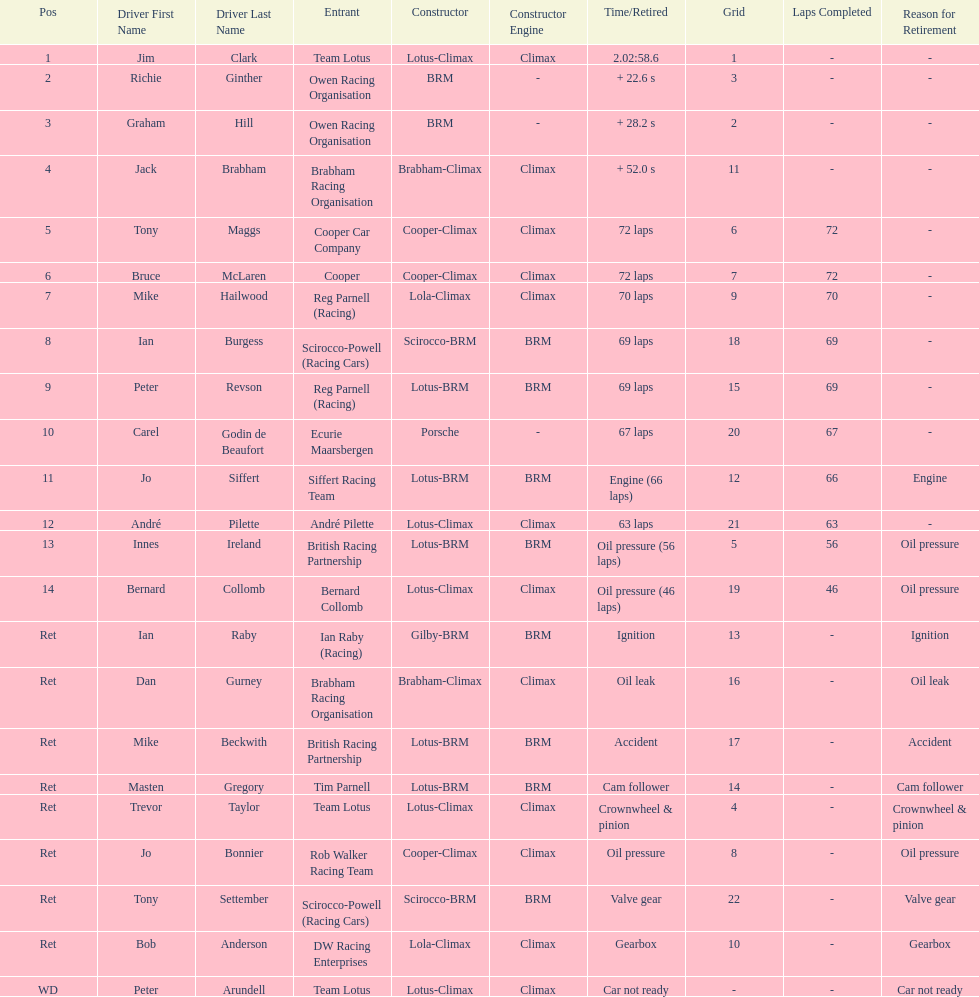Which driver did not have his/her car ready? Peter Arundell. 